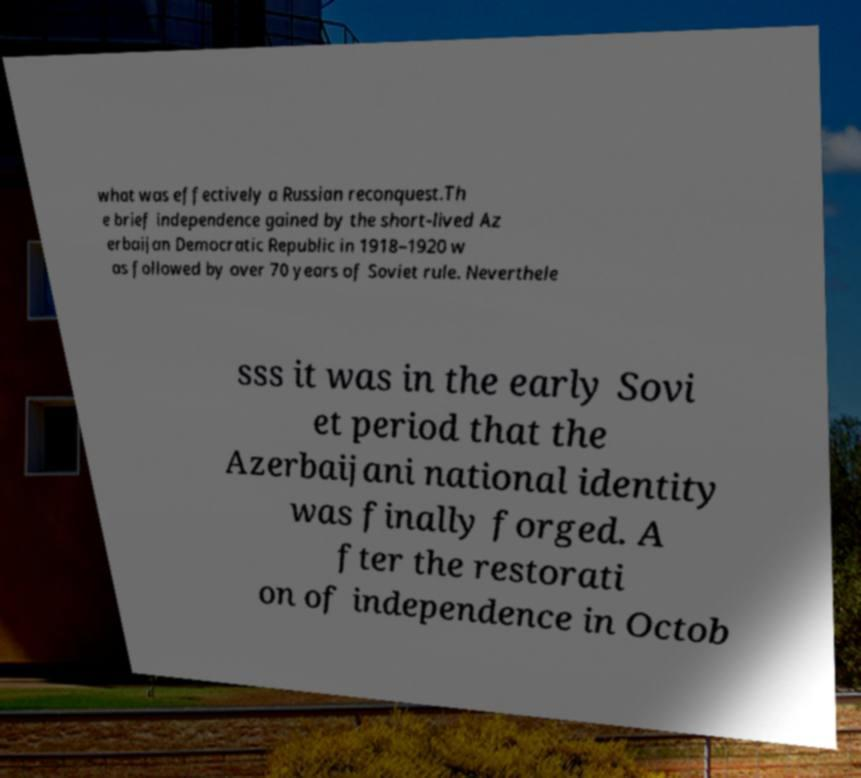Could you assist in decoding the text presented in this image and type it out clearly? what was effectively a Russian reconquest.Th e brief independence gained by the short-lived Az erbaijan Democratic Republic in 1918–1920 w as followed by over 70 years of Soviet rule. Neverthele sss it was in the early Sovi et period that the Azerbaijani national identity was finally forged. A fter the restorati on of independence in Octob 